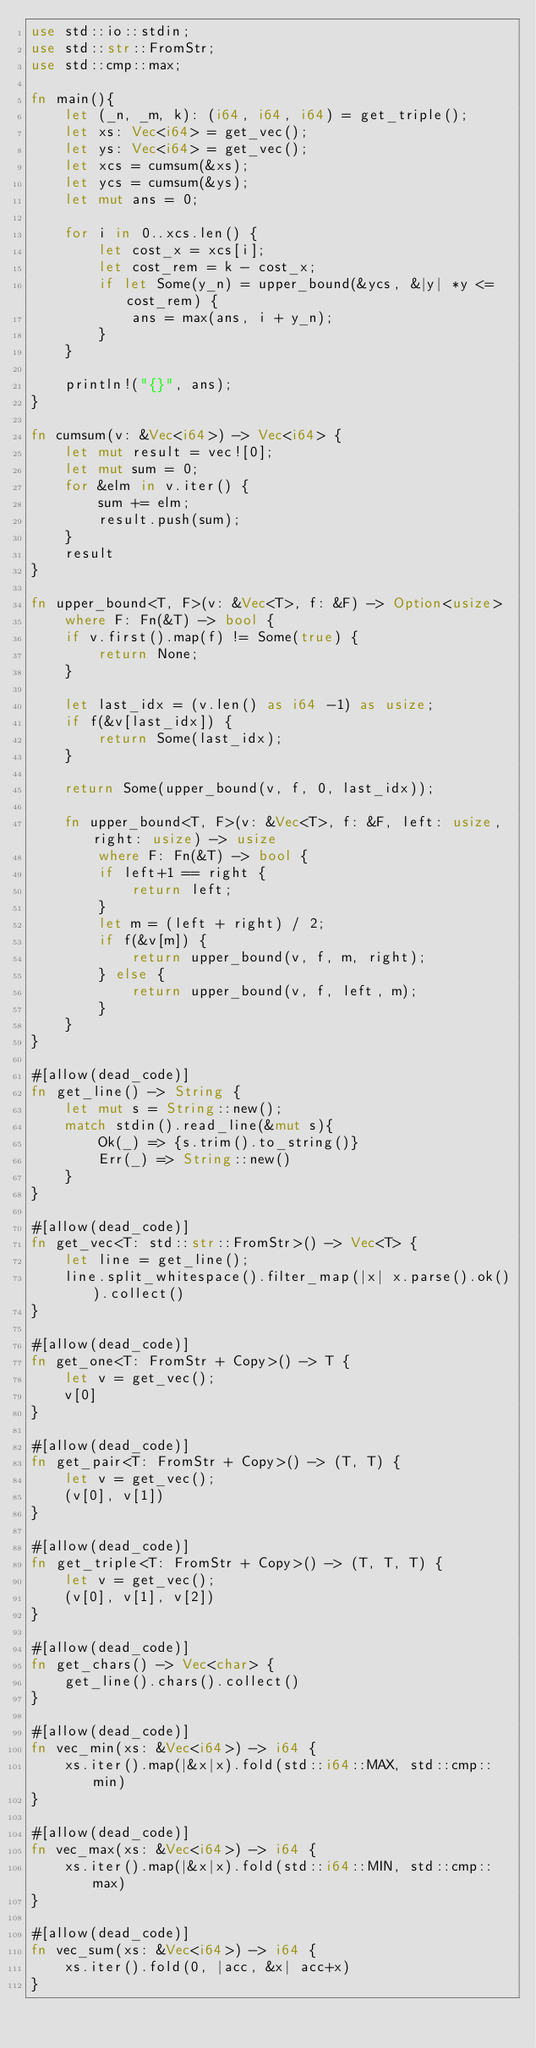Convert code to text. <code><loc_0><loc_0><loc_500><loc_500><_Rust_>use std::io::stdin;
use std::str::FromStr;
use std::cmp::max;

fn main(){
    let (_n, _m, k): (i64, i64, i64) = get_triple();
    let xs: Vec<i64> = get_vec();
    let ys: Vec<i64> = get_vec();
    let xcs = cumsum(&xs);
    let ycs = cumsum(&ys);
    let mut ans = 0;

    for i in 0..xcs.len() {
        let cost_x = xcs[i];
        let cost_rem = k - cost_x;
        if let Some(y_n) = upper_bound(&ycs, &|y| *y <= cost_rem) {
            ans = max(ans, i + y_n);
        } 
    }

    println!("{}", ans);
}

fn cumsum(v: &Vec<i64>) -> Vec<i64> {
    let mut result = vec![0];
    let mut sum = 0;
    for &elm in v.iter() {
        sum += elm;
        result.push(sum);
    }
    result
}

fn upper_bound<T, F>(v: &Vec<T>, f: &F) -> Option<usize>
    where F: Fn(&T) -> bool {
    if v.first().map(f) != Some(true) {
        return None;
    }

    let last_idx = (v.len() as i64 -1) as usize;
    if f(&v[last_idx]) {
        return Some(last_idx);
    }

    return Some(upper_bound(v, f, 0, last_idx));

    fn upper_bound<T, F>(v: &Vec<T>, f: &F, left: usize, right: usize) -> usize 
        where F: Fn(&T) -> bool {
        if left+1 == right {
            return left;
        }
        let m = (left + right) / 2;
        if f(&v[m]) {
            return upper_bound(v, f, m, right);
        } else {
            return upper_bound(v, f, left, m);
        }
    }
}

#[allow(dead_code)]
fn get_line() -> String {
    let mut s = String::new();
    match stdin().read_line(&mut s){
        Ok(_) => {s.trim().to_string()}
        Err(_) => String::new()
    }
}

#[allow(dead_code)]
fn get_vec<T: std::str::FromStr>() -> Vec<T> {
    let line = get_line();
    line.split_whitespace().filter_map(|x| x.parse().ok()).collect()
}

#[allow(dead_code)]
fn get_one<T: FromStr + Copy>() -> T {
    let v = get_vec();
    v[0]
}

#[allow(dead_code)]
fn get_pair<T: FromStr + Copy>() -> (T, T) {
    let v = get_vec();
    (v[0], v[1])
}

#[allow(dead_code)]
fn get_triple<T: FromStr + Copy>() -> (T, T, T) {
    let v = get_vec();
    (v[0], v[1], v[2])
}

#[allow(dead_code)]
fn get_chars() -> Vec<char> {
    get_line().chars().collect()
}

#[allow(dead_code)]
fn vec_min(xs: &Vec<i64>) -> i64 {
    xs.iter().map(|&x|x).fold(std::i64::MAX, std::cmp::min)
}

#[allow(dead_code)]
fn vec_max(xs: &Vec<i64>) -> i64 {
    xs.iter().map(|&x|x).fold(std::i64::MIN, std::cmp::max)
}

#[allow(dead_code)]
fn vec_sum(xs: &Vec<i64>) -> i64 {
    xs.iter().fold(0, |acc, &x| acc+x)
}
</code> 